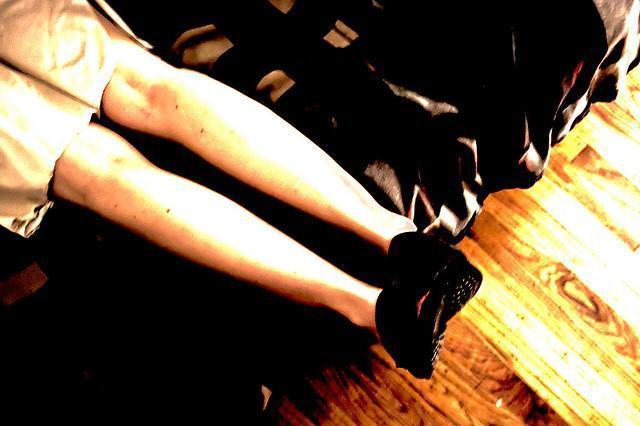How many people are there?
Give a very brief answer. 1. 